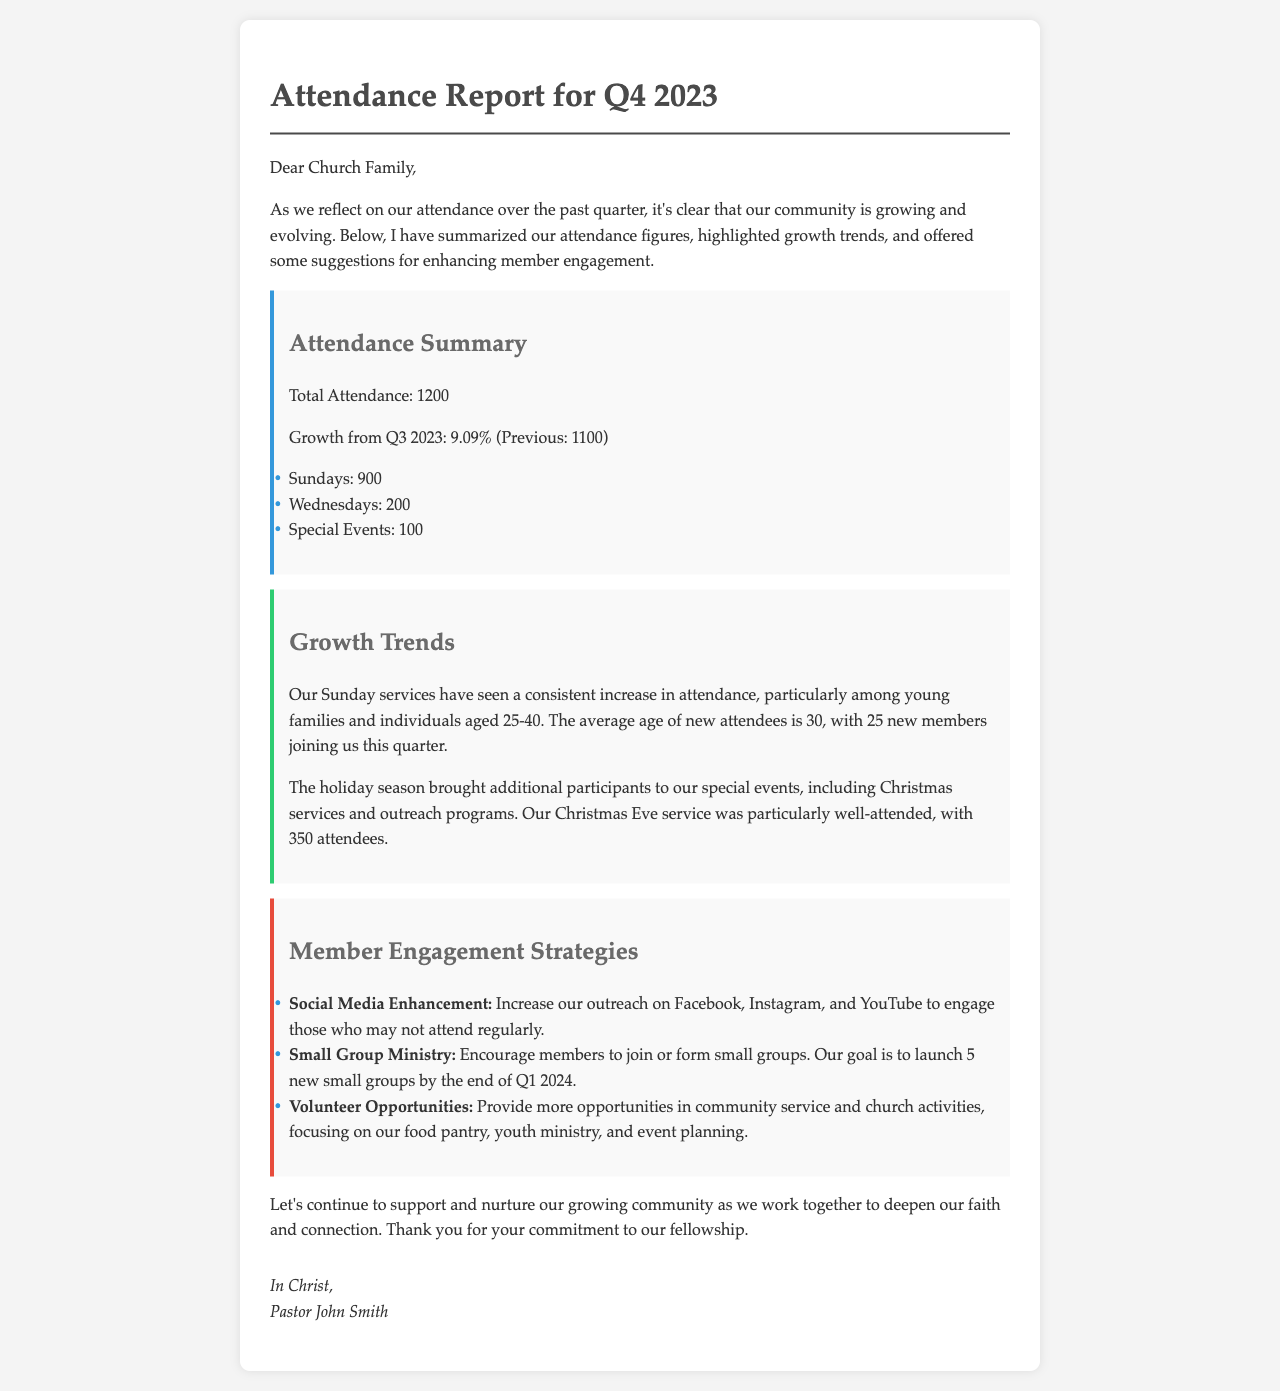What is the total attendance for Q4 2023? The total attendance is provided in the attendance summary section of the document.
Answer: 1200 What is the growth percentage from Q3 2023? The growth percentage is mentioned right after the total attendance figure in the summary.
Answer: 9.09% How many Sundays did the church have attendance records for? The number of Sundays is listed under the attendance summary as part of the breakdown.
Answer: 900 How many new members joined in Q4 2023? The document specifies the number of new members in the growth trends section.
Answer: 25 What age group has seen a consistent increase in Sunday services? This information is highlighted in the growth trends section regarding the demographics of attendees.
Answer: Young families and individuals aged 25-40 What is one of the suggested strategies for member engagement? This can be inferred from the engagement strategies section, which lists multiple strategies.
Answer: Social Media Enhancement What was the attendance for the Christmas Eve service? The document provides this attendance figure specifically within the growth trends section.
Answer: 350 How many new small groups are planned to be launched by the end of Q1 2024? The number of new small groups is mentioned as a goal in the engagement strategies section.
Answer: 5 Who signed the letter? The author of the letter is noted at the end of the document, indicating who it is from.
Answer: Pastor John Smith 